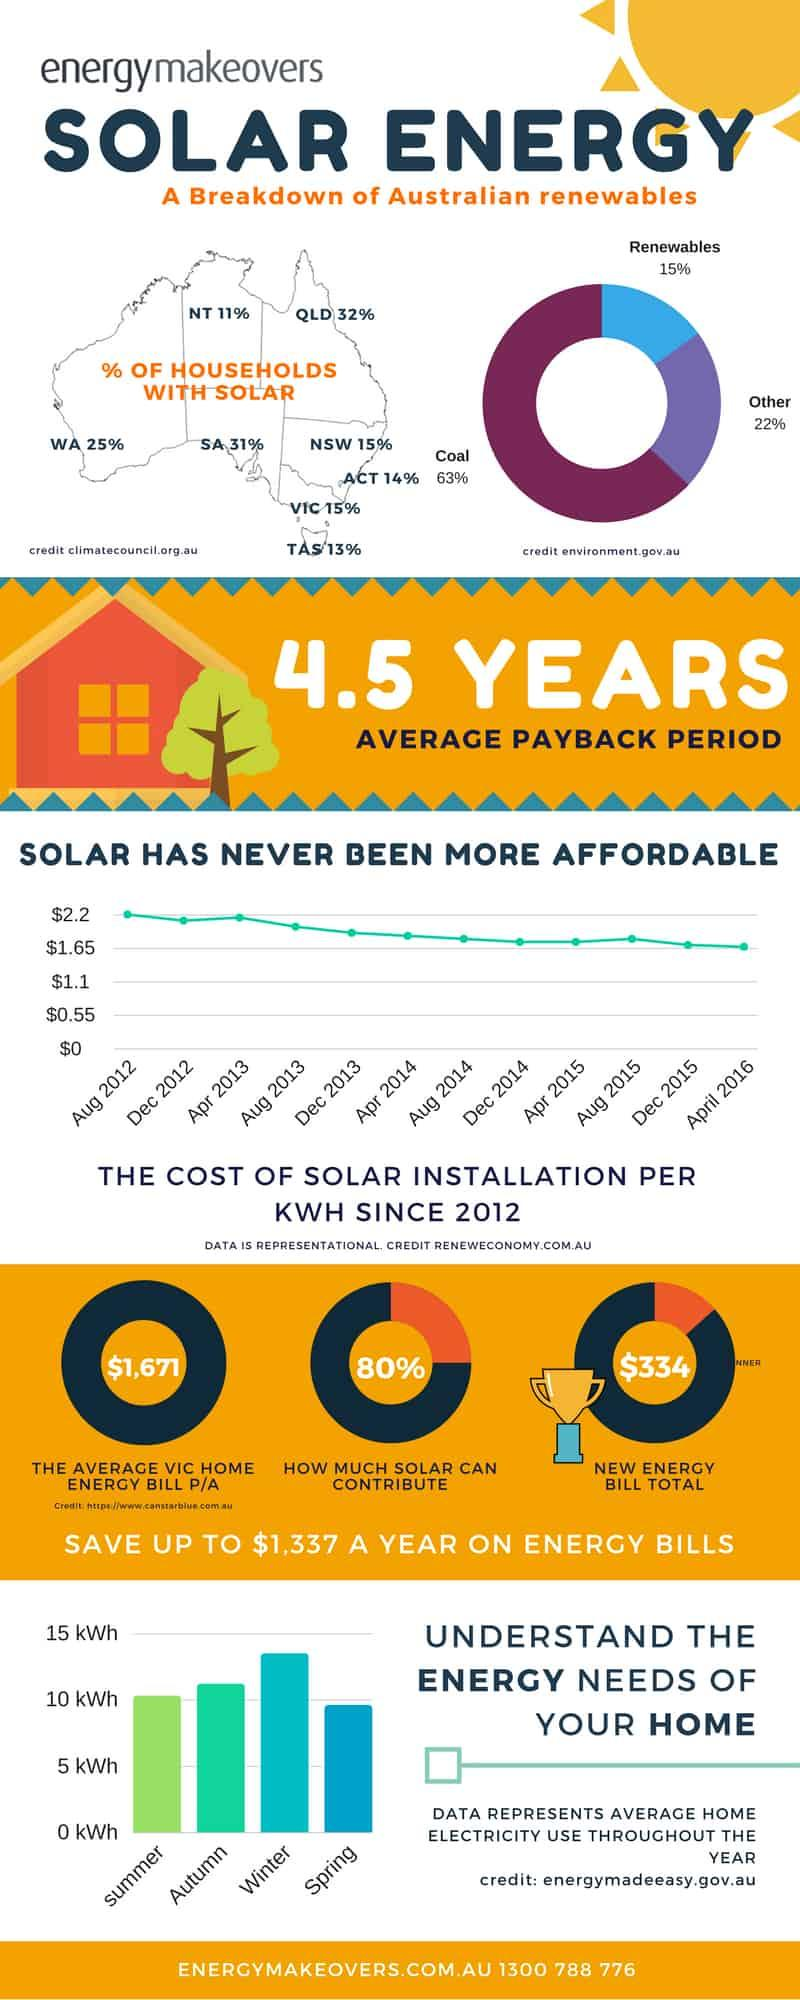Specify some key components in this picture. According to data, during the spring season, the average home electricity use is at its lowest point. The new energy bill total is $334. In August 2012, the cost of solar installation per kilowatt-hour was approximately $2.20. The average home electricity use is highest during the winter season. In Australia, approximately 15% of the energy generated comes from renewable sources. 